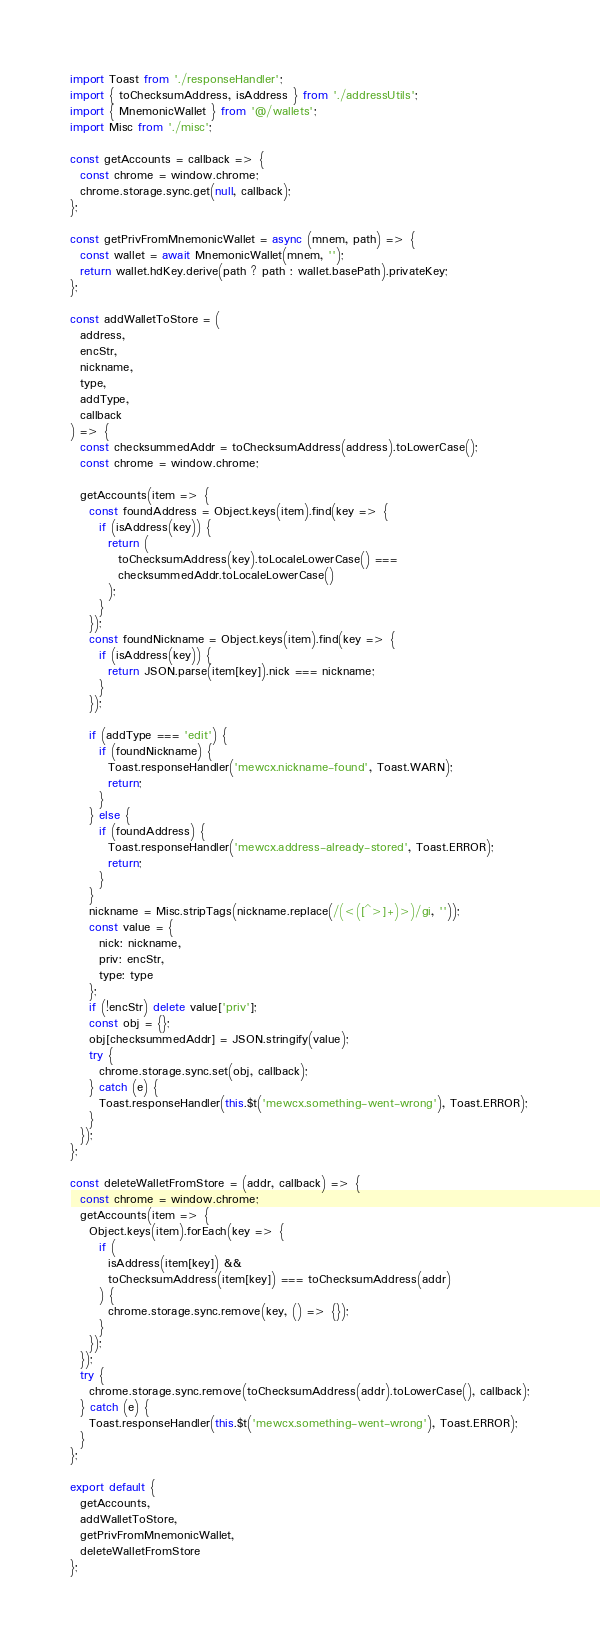<code> <loc_0><loc_0><loc_500><loc_500><_JavaScript_>import Toast from './responseHandler';
import { toChecksumAddress, isAddress } from './addressUtils';
import { MnemonicWallet } from '@/wallets';
import Misc from './misc';

const getAccounts = callback => {
  const chrome = window.chrome;
  chrome.storage.sync.get(null, callback);
};

const getPrivFromMnemonicWallet = async (mnem, path) => {
  const wallet = await MnemonicWallet(mnem, '');
  return wallet.hdKey.derive(path ? path : wallet.basePath).privateKey;
};

const addWalletToStore = (
  address,
  encStr,
  nickname,
  type,
  addType,
  callback
) => {
  const checksummedAddr = toChecksumAddress(address).toLowerCase();
  const chrome = window.chrome;

  getAccounts(item => {
    const foundAddress = Object.keys(item).find(key => {
      if (isAddress(key)) {
        return (
          toChecksumAddress(key).toLocaleLowerCase() ===
          checksummedAddr.toLocaleLowerCase()
        );
      }
    });
    const foundNickname = Object.keys(item).find(key => {
      if (isAddress(key)) {
        return JSON.parse(item[key]).nick === nickname;
      }
    });

    if (addType === 'edit') {
      if (foundNickname) {
        Toast.responseHandler('mewcx.nickname-found', Toast.WARN);
        return;
      }
    } else {
      if (foundAddress) {
        Toast.responseHandler('mewcx.address-already-stored', Toast.ERROR);
        return;
      }
    }
    nickname = Misc.stripTags(nickname.replace(/(<([^>]+)>)/gi, ''));
    const value = {
      nick: nickname,
      priv: encStr,
      type: type
    };
    if (!encStr) delete value['priv'];
    const obj = {};
    obj[checksummedAddr] = JSON.stringify(value);
    try {
      chrome.storage.sync.set(obj, callback);
    } catch (e) {
      Toast.responseHandler(this.$t('mewcx.something-went-wrong'), Toast.ERROR);
    }
  });
};

const deleteWalletFromStore = (addr, callback) => {
  const chrome = window.chrome;
  getAccounts(item => {
    Object.keys(item).forEach(key => {
      if (
        isAddress(item[key]) &&
        toChecksumAddress(item[key]) === toChecksumAddress(addr)
      ) {
        chrome.storage.sync.remove(key, () => {});
      }
    });
  });
  try {
    chrome.storage.sync.remove(toChecksumAddress(addr).toLowerCase(), callback);
  } catch (e) {
    Toast.responseHandler(this.$t('mewcx.something-went-wrong'), Toast.ERROR);
  }
};

export default {
  getAccounts,
  addWalletToStore,
  getPrivFromMnemonicWallet,
  deleteWalletFromStore
};
</code> 